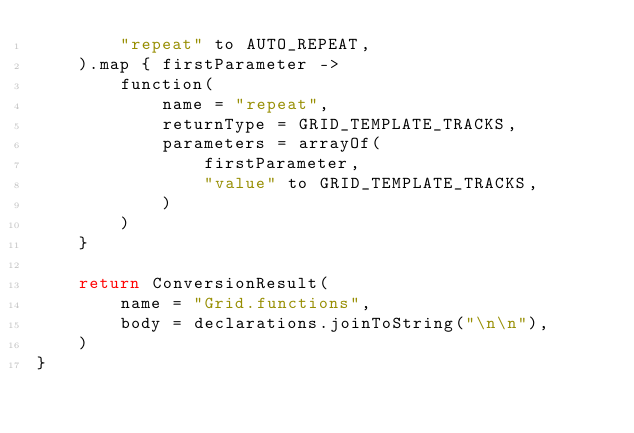Convert code to text. <code><loc_0><loc_0><loc_500><loc_500><_Kotlin_>        "repeat" to AUTO_REPEAT,
    ).map { firstParameter ->
        function(
            name = "repeat",
            returnType = GRID_TEMPLATE_TRACKS,
            parameters = arrayOf(
                firstParameter,
                "value" to GRID_TEMPLATE_TRACKS,
            )
        )
    }

    return ConversionResult(
        name = "Grid.functions",
        body = declarations.joinToString("\n\n"),
    )
}
</code> 